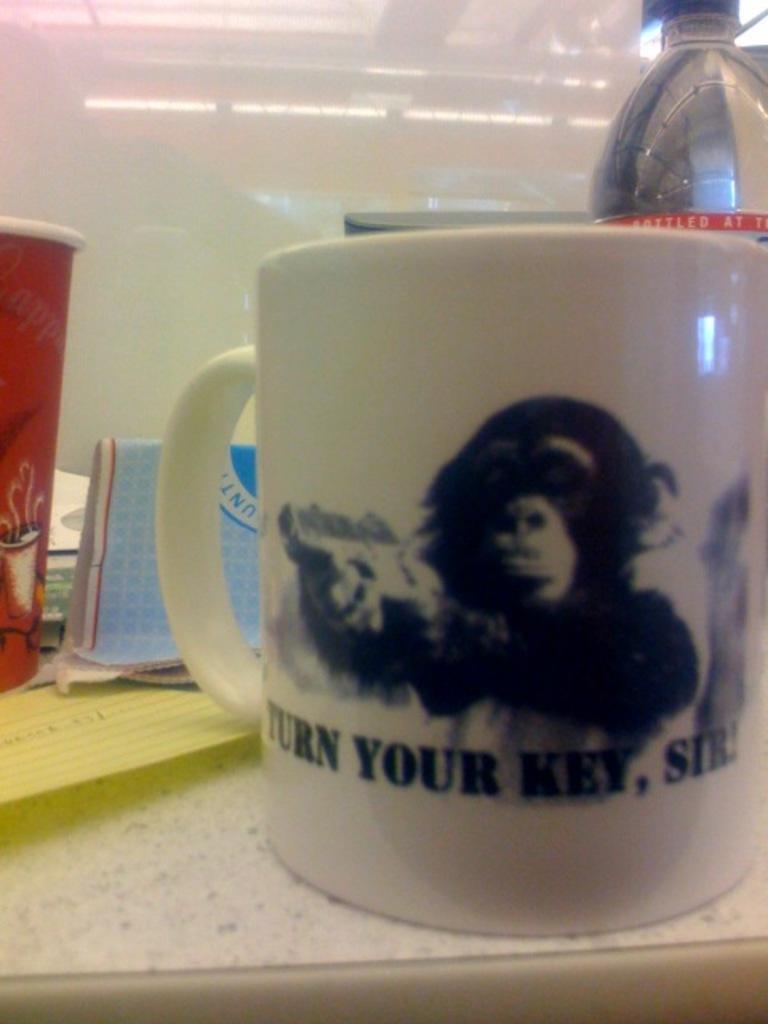Could you give a brief overview of what you see in this image? In this image we can see a cup with the picture of a monkey and some text on it which is placed on the surface. We can also see some papers, a bottle and a glass placed beside it. On the backside we can see a wall. 